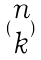Convert formula to latex. <formula><loc_0><loc_0><loc_500><loc_500>( \begin{matrix} n \\ k \end{matrix} )</formula> 